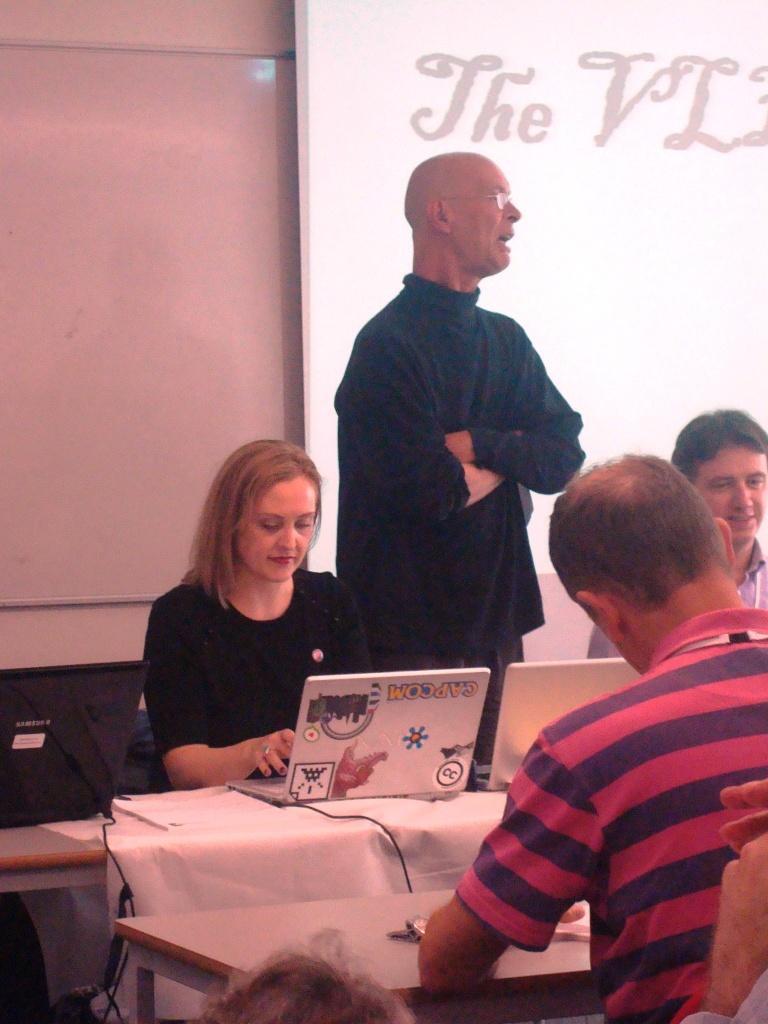Could you give a brief overview of what you see in this image? In the picture I can see people among them one man is standing and others are sitting in front of tables. On tables I can see laptops and some other objects. In the background I can see a white color board and a projector screen. 